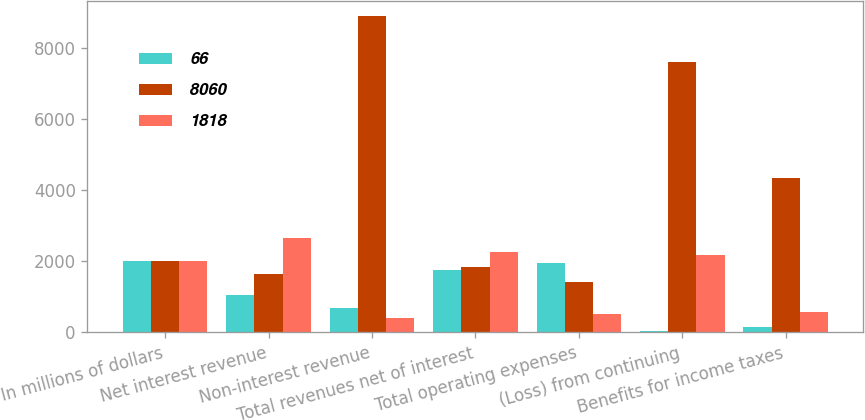Convert chart. <chart><loc_0><loc_0><loc_500><loc_500><stacked_bar_chart><ecel><fcel>In millions of dollars<fcel>Net interest revenue<fcel>Non-interest revenue<fcel>Total revenues net of interest<fcel>Total operating expenses<fcel>(Loss) from continuing<fcel>Benefits for income taxes<nl><fcel>66<fcel>2010<fcel>1059<fcel>695<fcel>1754<fcel>1953<fcel>46<fcel>153<nl><fcel>8060<fcel>2009<fcel>1657<fcel>8898<fcel>1853.5<fcel>1418<fcel>7617<fcel>4356<nl><fcel>1818<fcel>2008<fcel>2671<fcel>413<fcel>2258<fcel>511<fcel>2184<fcel>585<nl></chart> 